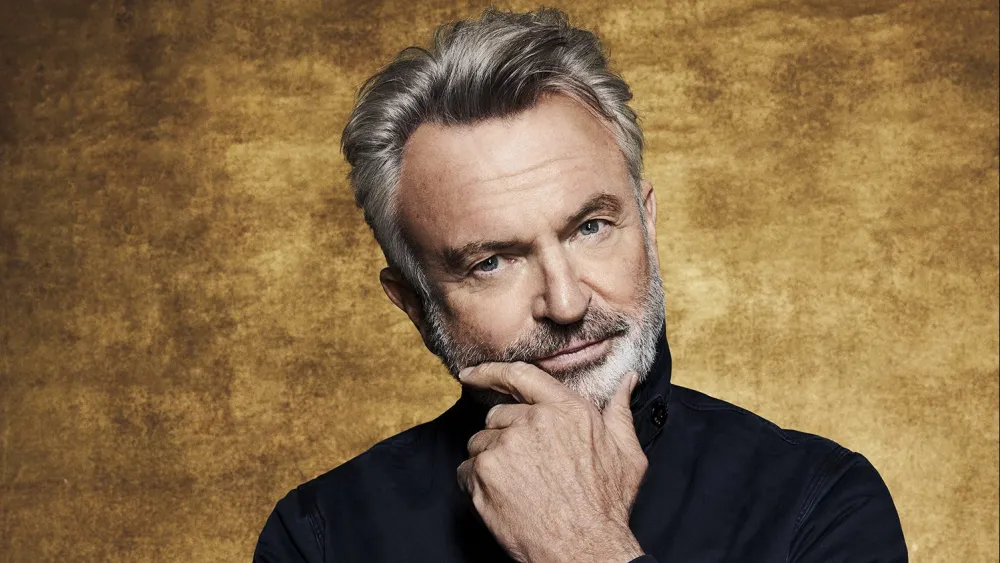What might be the inspiration behind the portrait? This portrait might draw inspiration from classical painting techniques, where the use of warm tones and deliberate lighting create a mood that invites the viewer into the subject's inner world. The person's attire and pose could be intended to invoke a timeless elegance, capturing a moment that transcends the immediate context. 